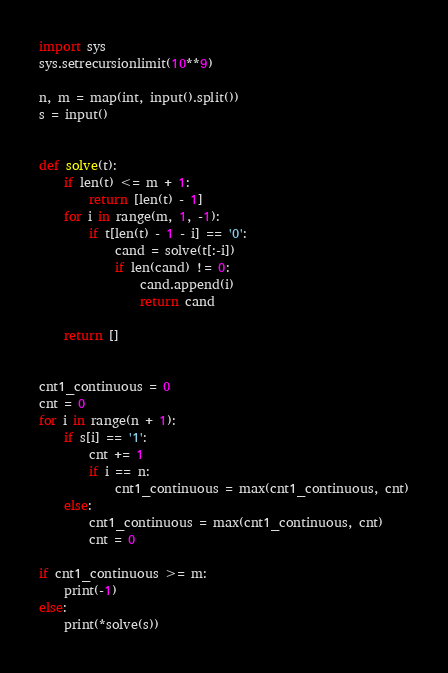<code> <loc_0><loc_0><loc_500><loc_500><_Python_>import sys
sys.setrecursionlimit(10**9)

n, m = map(int, input().split())
s = input()


def solve(t):
    if len(t) <= m + 1:
        return [len(t) - 1]
    for i in range(m, 1, -1):
        if t[len(t) - 1 - i] == '0':
            cand = solve(t[:-i])
            if len(cand) != 0:
                cand.append(i)
                return cand

    return []


cnt1_continuous = 0
cnt = 0
for i in range(n + 1):
    if s[i] == '1':
        cnt += 1
        if i == n:
            cnt1_continuous = max(cnt1_continuous, cnt)
    else:
        cnt1_continuous = max(cnt1_continuous, cnt)
        cnt = 0

if cnt1_continuous >= m:
    print(-1)
else:
    print(*solve(s))
</code> 